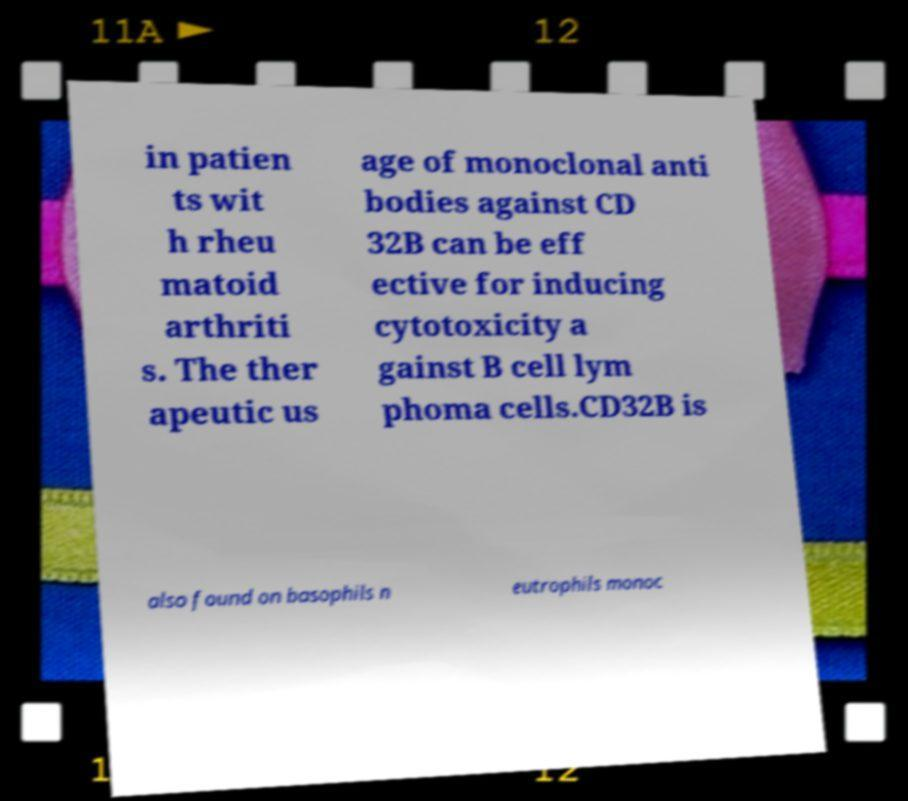Can you accurately transcribe the text from the provided image for me? in patien ts wit h rheu matoid arthriti s. The ther apeutic us age of monoclonal anti bodies against CD 32B can be eff ective for inducing cytotoxicity a gainst B cell lym phoma cells.CD32B is also found on basophils n eutrophils monoc 